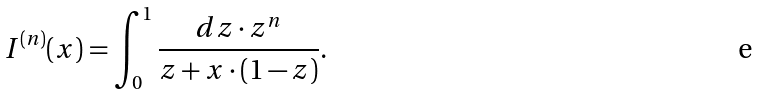Convert formula to latex. <formula><loc_0><loc_0><loc_500><loc_500>I ^ { ( n ) } ( x ) = \int _ { 0 } ^ { 1 } \frac { d z \cdot z ^ { n } } { z + x \cdot ( 1 - z ) } .</formula> 